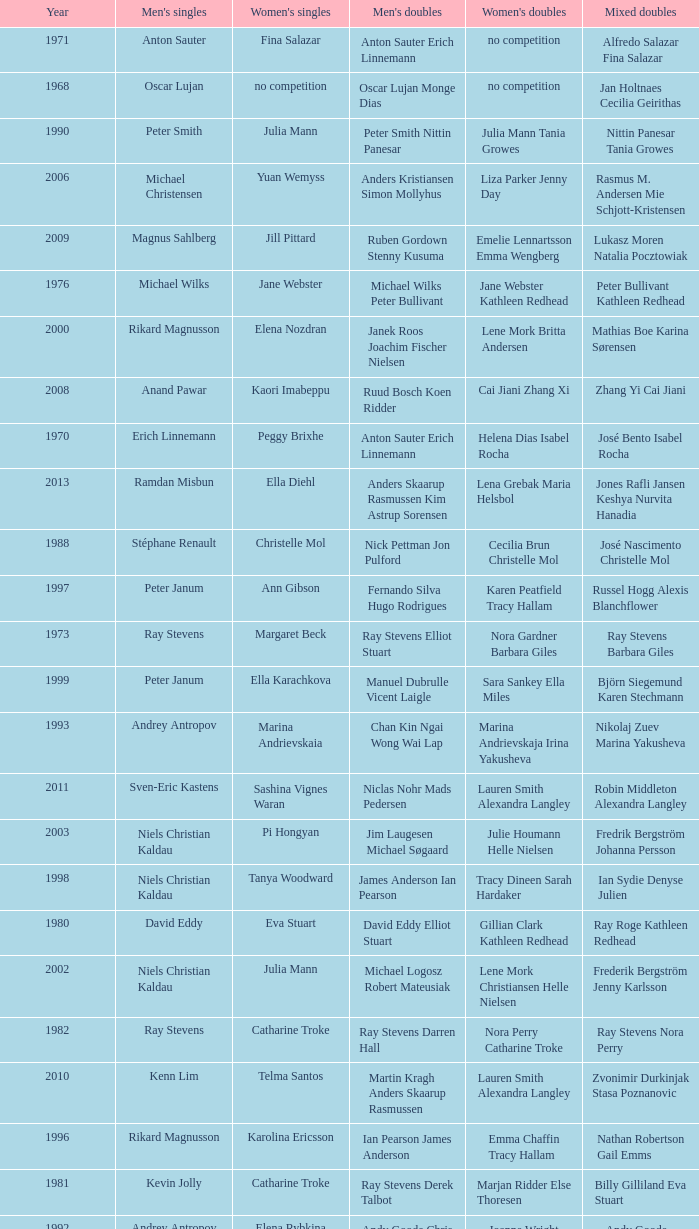What is the average year with alfredo salazar fina salazar in mixed doubles? 1971.0. 